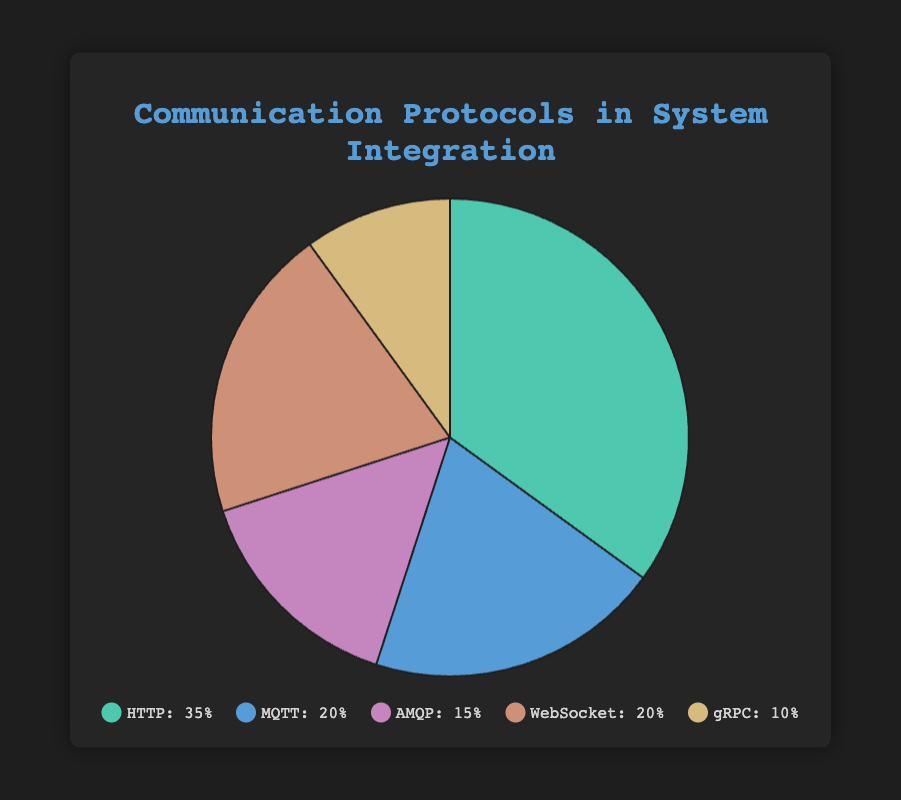What are the top two communication protocols by usage percentage? The two largest sections of the pie chart are HTTP and MQTT/WebSocket, with HTTP being the largest slice at 35% and MQTT/WebSocket having 20% each.
Answer: HTTP and MQTT/WebSocket Which protocol has the lowest usage percentage? The smallest slice of the pie chart represents gRPC, which is 10%.
Answer: gRPC What is the combined usage percentage of MQTT and WebSocket? Both MQTT and WebSocket each have a usage percentage of 20%. Adding these together gives 20% + 20% = 40%.
Answer: 40% How much larger is HTTP's usage percentage compared to AMQP's? HTTP has a usage of 35%, and AMQP has a usage of 15%. The difference is 35% - 15% = 20%.
Answer: 20% If the usage percentage of HTTP and MQTT were combined, what percentage of the total would they represent? HTTP has 35% and MQTT has 20%. Combined they represent 35% + 20% = 55% of the total.
Answer: 55% Which color represents WebSocket in the pie chart? WebSocket is represented by a visually unique color, which is identified as orange in the chart.
Answer: Orange What is the average usage percentage of all protocols? The total usage is 35% (HTTP) + 20% (MQTT) + 15% (AMQP) + 20% (WebSocket) + 10% (gRPC) which equals 100%. There are 5 protocols, so the average usage is 100%/5 = 20%.
Answer: 20% Is the difference between the usage percentages of HTTP and gRPC greater than the combined usage percentage of AMQP and gRPC? Difference between HTTP and gRPC is 35% - 10% = 25%. Combined usage of AMQP (15%) and gRPC (10%) is 15% + 10% = 25%. The difference is equal to the combined usage.
Answer: No Between MQTT and AMQP, which protocol has higher usage, and by how much? MQTT has a 20% usage, and AMQP has a 15% usage. The difference is 20% - 15% = 5%.
Answer: MQTT by 5% Which protocol pair, if combined, would not exceed HTTP's usage percentage when added together? AMQP and gRPC can be paired: AMQP (15%) + gRPC (10%) = 25%, which is less than HTTP's 35%. Other combinations involving higher percentages would exceed 35%.
Answer: AMQP and gRPC 